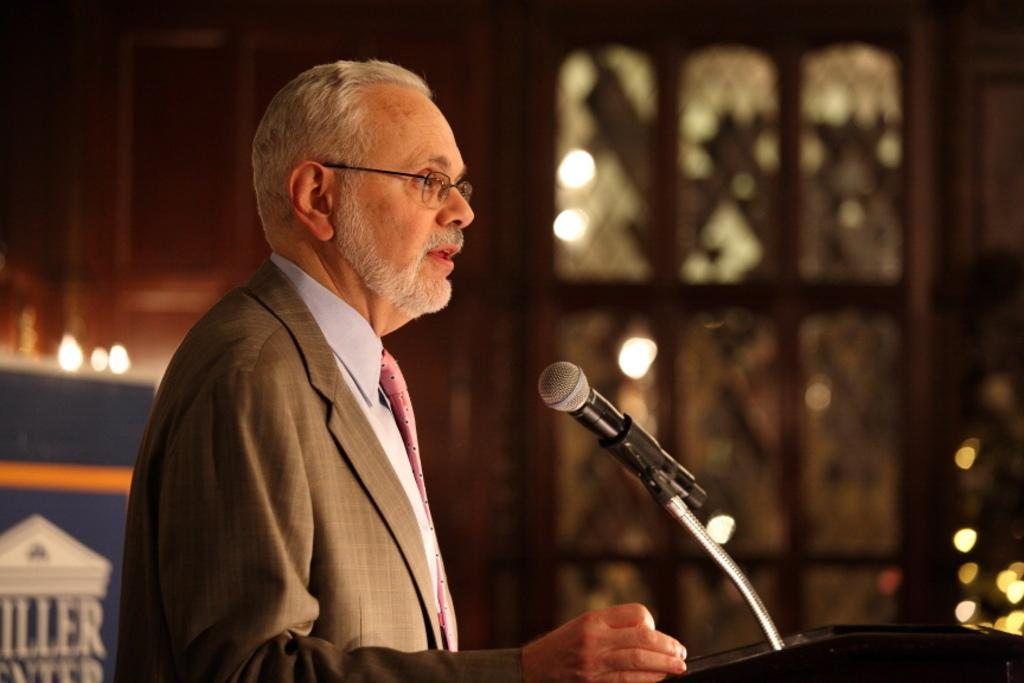What is the person in the image doing? The person is standing in front of the podium. What is on the podium? There is a mic on the podium. What is behind the person? There is a board with an image behind the person. What can be seen through the windows in the image? The presence of windows is mentioned, but their contents are not specified. What type of skirt is the person wearing in the image? The provided facts do not mention any clothing details, so we cannot determine the type of skirt the person is wearing. 